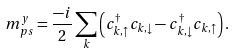Convert formula to latex. <formula><loc_0><loc_0><loc_500><loc_500>m _ { p s } ^ { y } = \frac { - i } { 2 } \sum _ { k } \left ( c ^ { \dagger } _ { k , \uparrow } c _ { k , \downarrow } - c ^ { \dagger } _ { k , \downarrow } c _ { k , \uparrow } \right ) .</formula> 